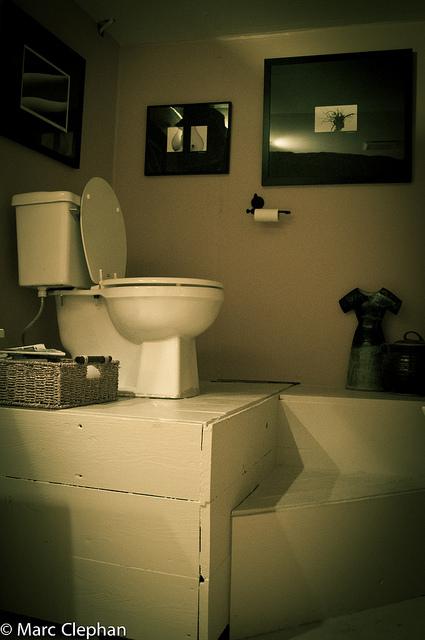How many humans in this picture?
Short answer required. 0. Is there a roach sitting on the toilet?
Answer briefly. No. Is there toilet paper?
Keep it brief. Yes. Are there pictures on the wall?
Concise answer only. Yes. 